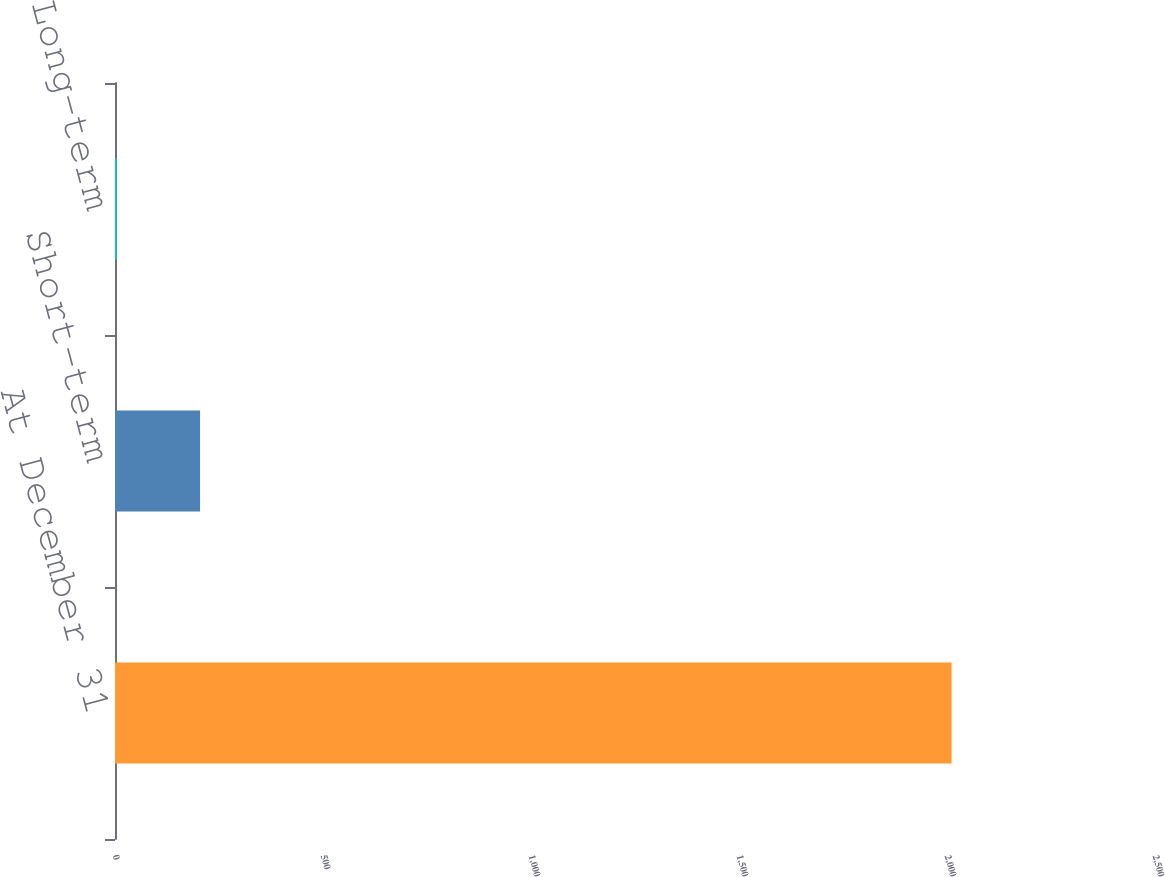Convert chart. <chart><loc_0><loc_0><loc_500><loc_500><bar_chart><fcel>At December 31<fcel>Short-term<fcel>Long-term<nl><fcel>2011<fcel>204.48<fcel>3.76<nl></chart> 